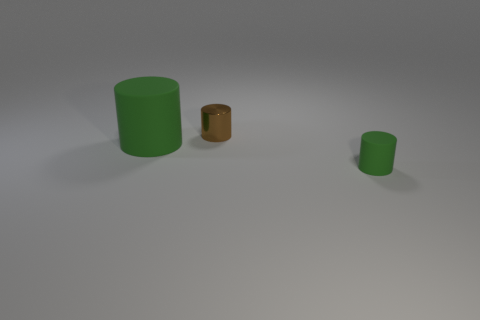Add 2 big brown matte blocks. How many objects exist? 5 Subtract all red metallic blocks. Subtract all small rubber objects. How many objects are left? 2 Add 2 small things. How many small things are left? 4 Add 2 green objects. How many green objects exist? 4 Subtract 0 yellow balls. How many objects are left? 3 